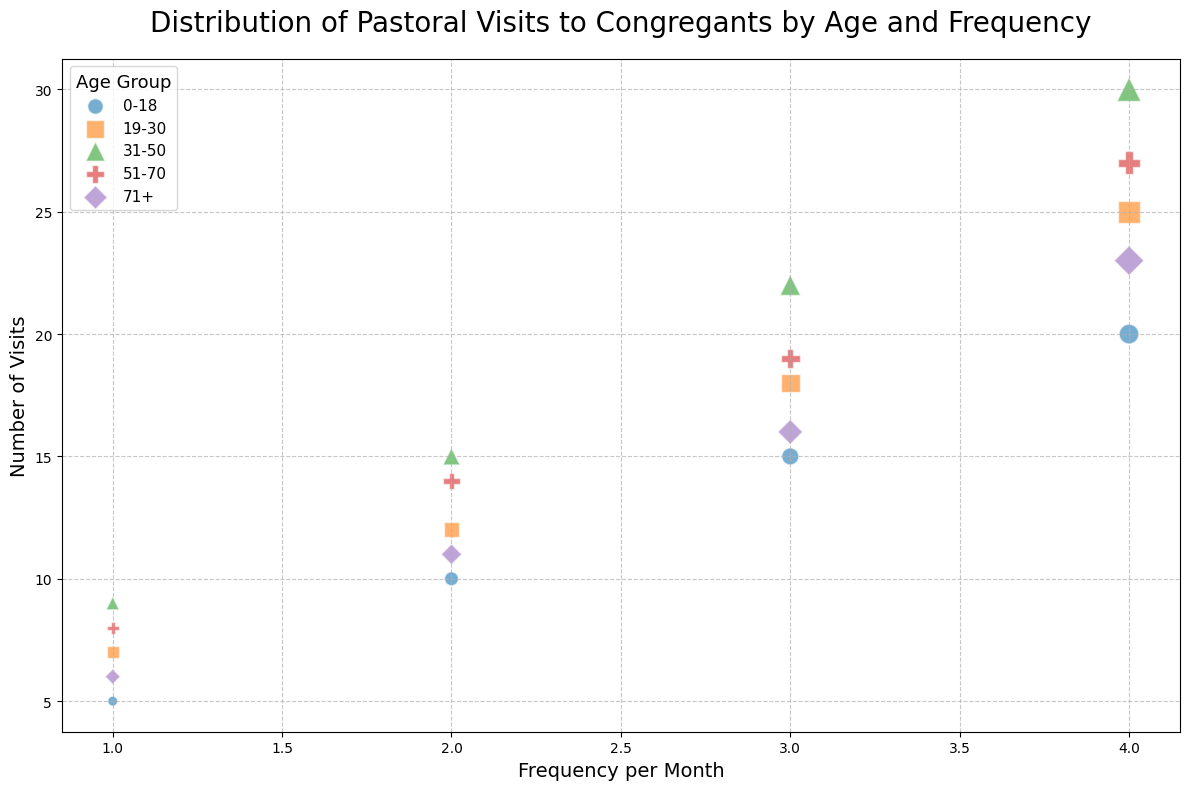What age group sees the highest number of visits? Observing the scatter plot, the size of the bubbles indicates the number of visits. For the age group 31-50 with a frequency of 4 per month, the largest bubbles indicate that 30 visits occur.
Answer: 31-50 How do the number of visits for the age group 19-30 compare at a frequency of 2 visits per month to 4 visits per month? For the age group 19-30, the number of visits at 2 visits per month is shown by a smaller bubble with 12 visits. At 4 visits per month, the bubble size indicates 25 visits. Comparing the two, 25 visits are greater than 12 visits.
Answer: 25 visits are greater than 12 visits What is the sum of the visits for age groups 51-70 and 71+ at a frequency of 3 visits per month? For a frequency of 3 visits per month, the bubbles with the number of visits for age groups 51-70 and 71+ display values of 19 and 16, respectively. Summing these gives 19 + 16 = 35.
Answer: 35 Which age group has the fewest visits at 1 visit per month, and what is the number? Looking at the bubbles corresponding to 1 visit per month, age group 0-18 has the fewest visits, with a bubble representing 5 visits.
Answer: 0-18 with 5 visits Are the visits for age group 31-50 more or fewer compared to age group 71+ at a frequency of 4 visits per month? Comparing the sizes of the bubbles, age group 31-50 has 30 visits, while age group 71+ has 23 visits for a frequency of 4 visits per month. 30 visits (31-50) are greater than 23 visits (71+).
Answer: More What is the average number of visits across all age groups for a frequency of 2 visits per month? Calculating the average involves summing the visits for each age group at 2 visits per month and then dividing by the number of groups: (10 + 12 + 15 + 14 + 11) / 5 = 62 / 5 = 12.4.
Answer: 12.4 How many more visits does the age group 31-50 receive compared to the 0-18 age group at 3 visits per month? The scatter plot shows 22 visits for the age group 31-50 and 15 visits for the 0-18 age group. The difference is 22 - 15 = 7.
Answer: 7 Which age group is represented by the purple bubbles, and how many visits do they have for a frequency of 1 visit per month? In the scatter plot, the purple bubbles represent the age group 71+, which shows 6 visits for 1 visit per month.
Answer: 71+ with 6 visits 